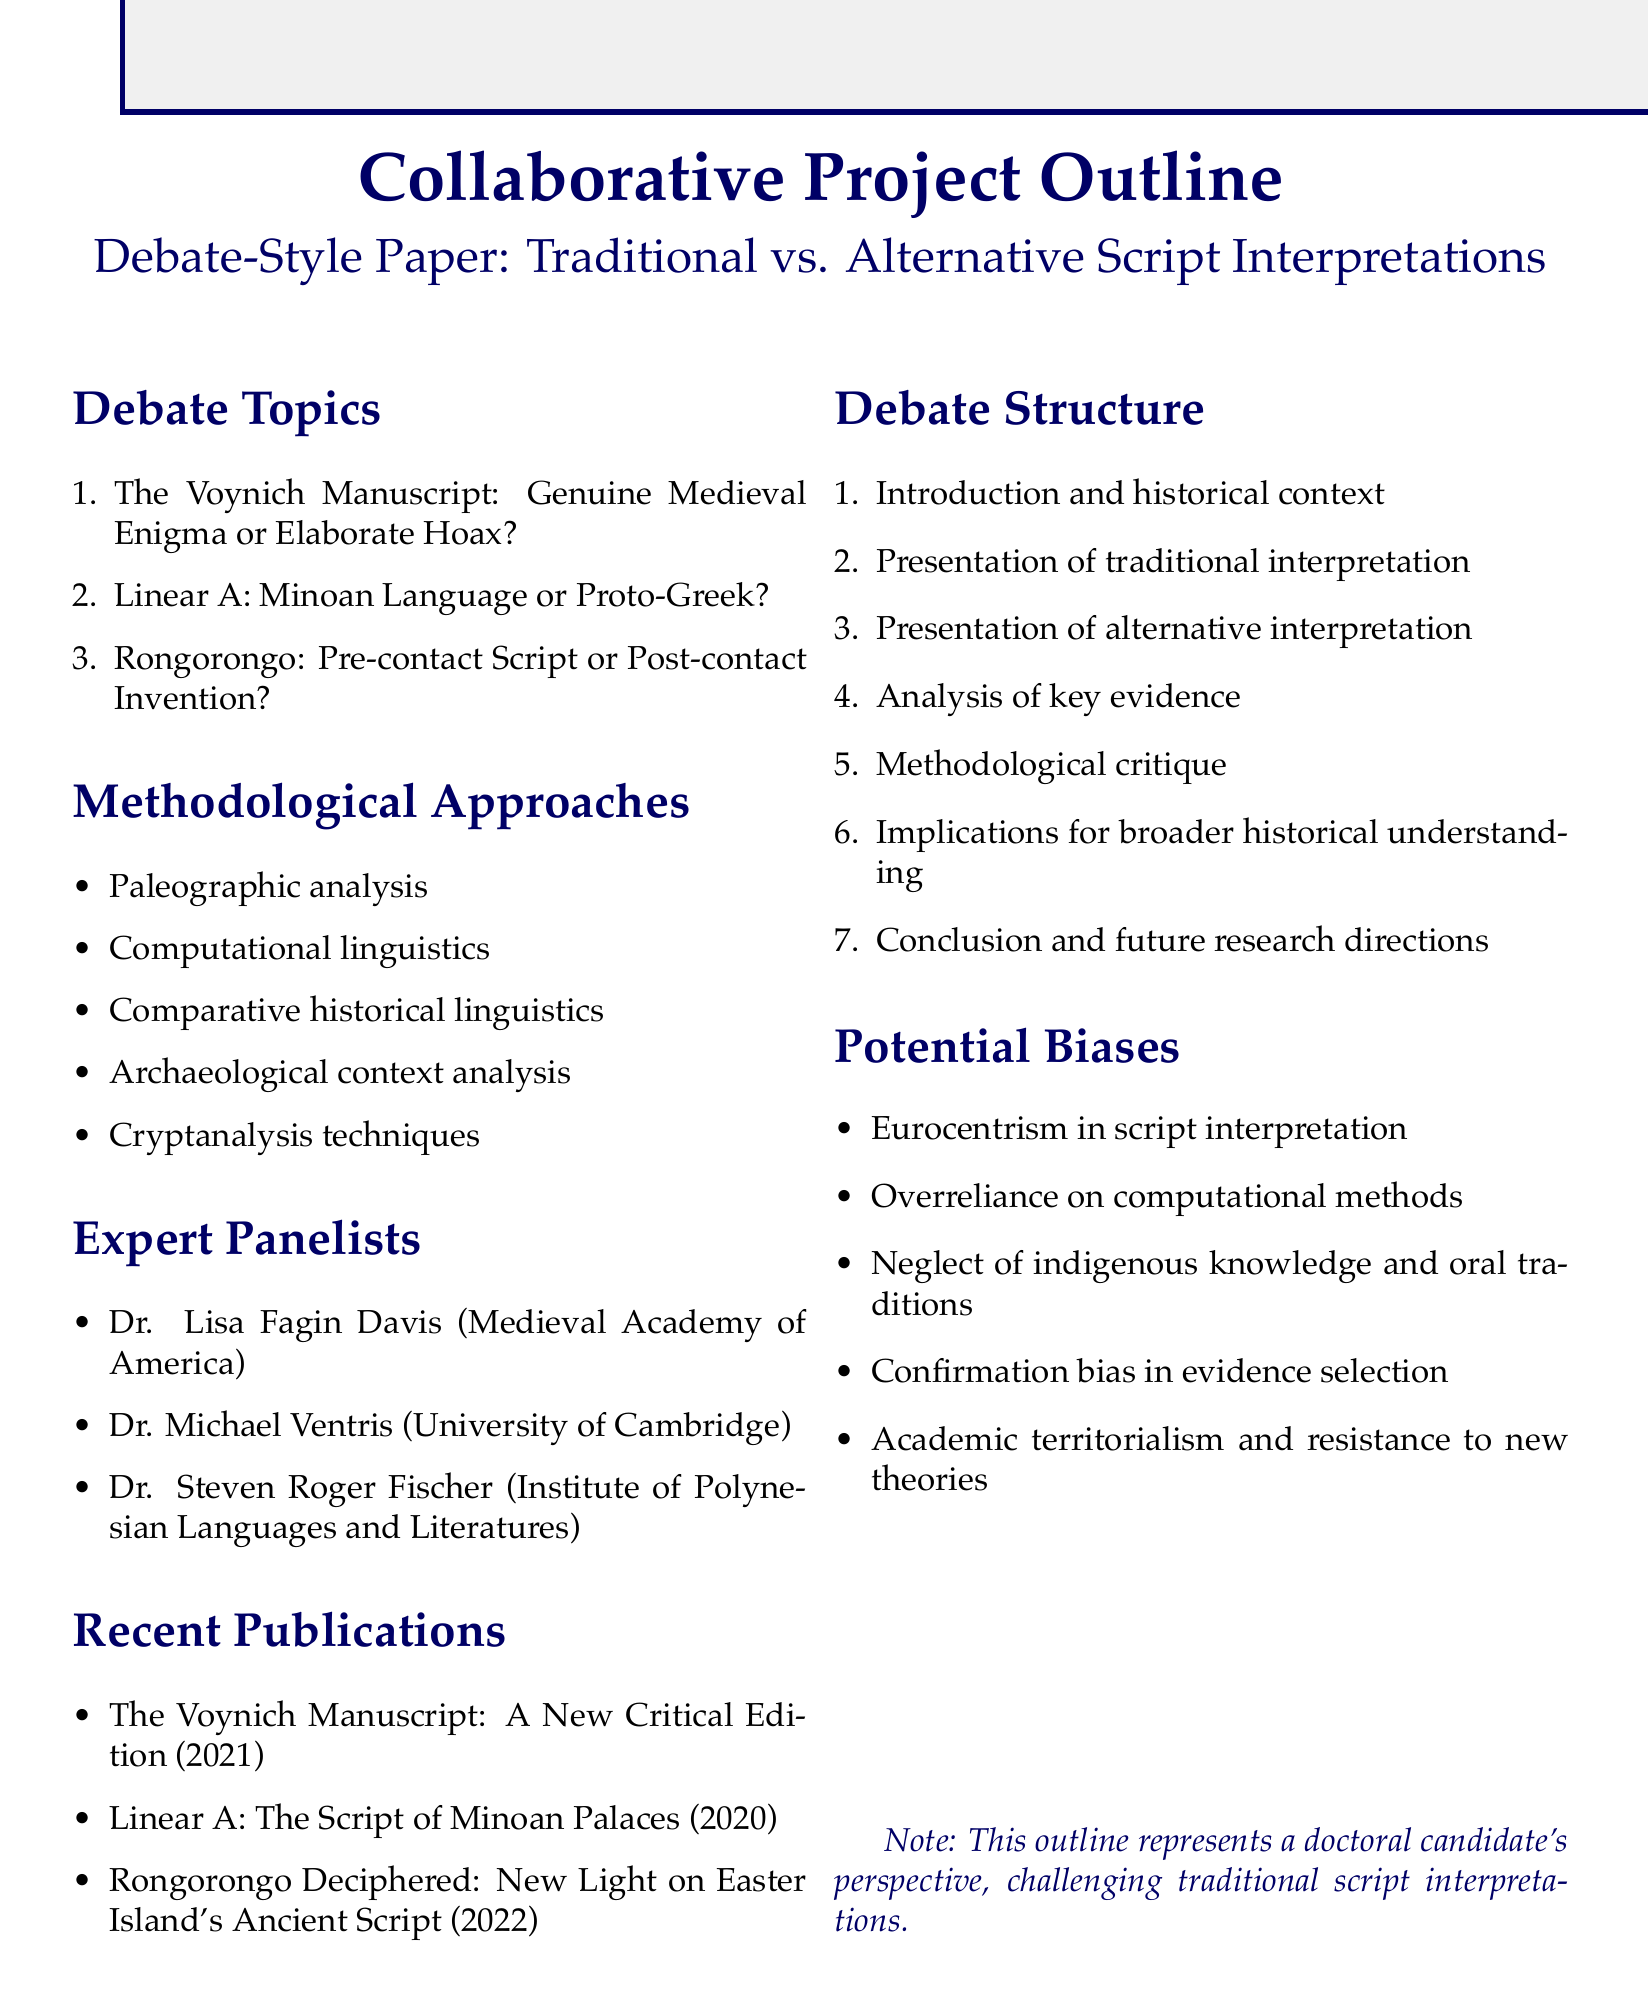What is the title of the first debate topic? The title of the first debate topic is specifically listed in the document, which is "The Voynich Manuscript: Genuine Medieval Enigma or Elaborate Hoax?"
Answer: The Voynich Manuscript: Genuine Medieval Enigma or Elaborate Hoax? Who authored the publication about Linear A? The document lists recent publications along with their authors, indicating that "Linear A: The Script of Minoan Palaces" is authored by John Younger.
Answer: John Younger What year was the publication on Rongorongo released? The document provides information about the publication years, stating that "Rongorongo Deciphered: New Light on Easter Island's Ancient Script" was published in 2022.
Answer: 2022 How many expert panelists are listed in the document? The document enumerates the expert panelists, revealing that there are three listed panelists.
Answer: 3 What methodological approach concerns the analysis of writing systems? The document lists various methodological approaches and identifies "Paleographic analysis" as related to the study of writing systems.
Answer: Paleographic analysis What is one of the potential biases mentioned? The document outlines various potential biases, and one noted is "Neglect of indigenous knowledge and oral traditions."
Answer: Neglect of indigenous knowledge and oral traditions What is the last step in the debate structure? The debate structure includes several steps and concludes with the step "Conclusion and future research directions."
Answer: Conclusion and future research directions What is the affiliation of Dr. Steven Roger Fischer? The document provides affiliations for expert panelists, indicating that Dr. Steven Roger Fischer is affiliated with the Institute of Polynesian Languages and Literatures.
Answer: Institute of Polynesian Languages and Literatures 